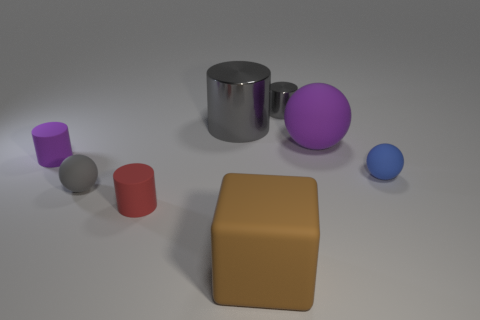Add 1 brown blocks. How many objects exist? 9 Subtract all cyan cylinders. Subtract all yellow spheres. How many cylinders are left? 4 Subtract all cubes. How many objects are left? 7 Subtract all brown spheres. Subtract all gray rubber spheres. How many objects are left? 7 Add 4 small matte cylinders. How many small matte cylinders are left? 6 Add 4 red metal blocks. How many red metal blocks exist? 4 Subtract 1 red cylinders. How many objects are left? 7 